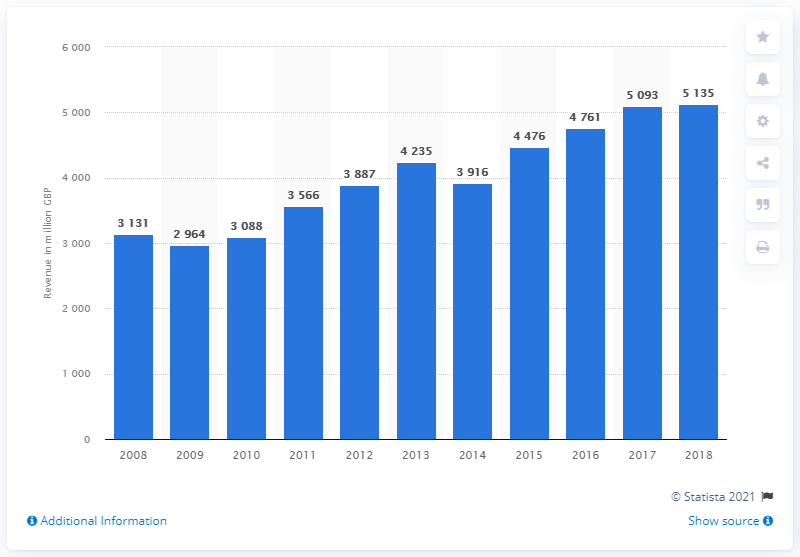Outline some significant characteristics in this image. In 2008, the retail revenue from tools and equipment totaled $5,135. By 2018, this amount had increased to $5,135. The retail revenue for tools and equipment in the UK in 2008 was 3131. 